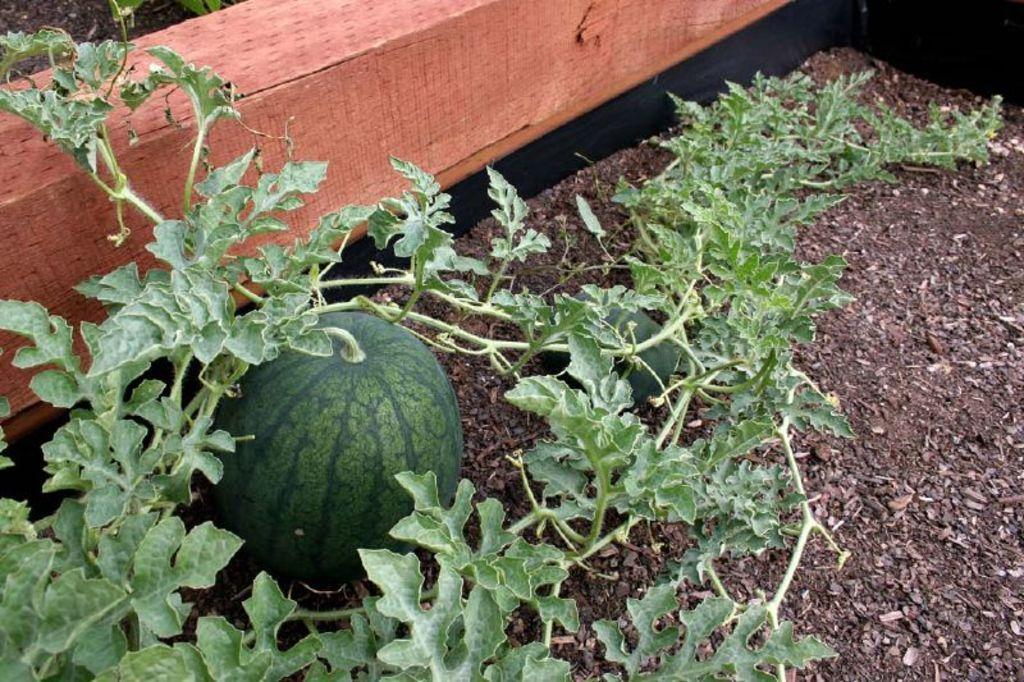Please provide a concise description of this image. In this image in the front there are plants and there are fruits. In the background there is an object. 